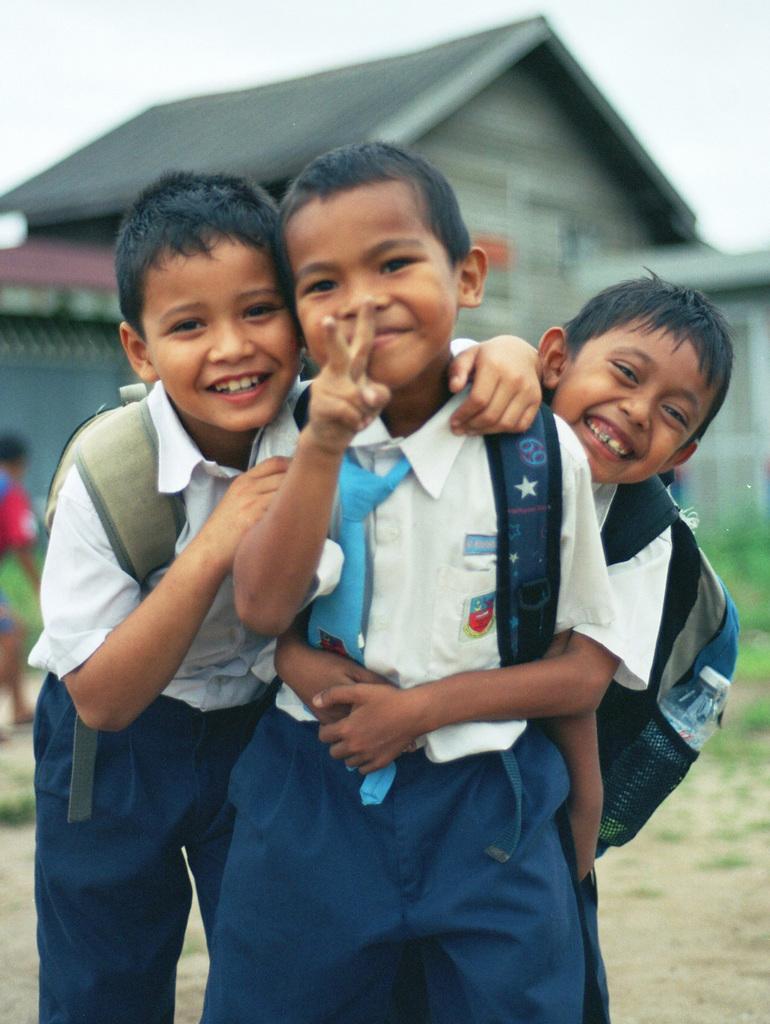Describe this image in one or two sentences. In the center of the image we can see three boys standing and smiling. In the background there is a building and sky. On the left there is a lady. 